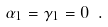Convert formula to latex. <formula><loc_0><loc_0><loc_500><loc_500>\alpha _ { 1 } = \gamma _ { 1 } = 0 \ .</formula> 